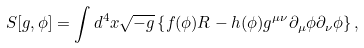<formula> <loc_0><loc_0><loc_500><loc_500>S [ g , \phi ] = \int d ^ { 4 } x \sqrt { - g } \left \{ f ( \phi ) R - h ( \phi ) g ^ { \mu \nu } \partial _ { \mu } \phi \partial _ { \nu } \phi \right \} ,</formula> 